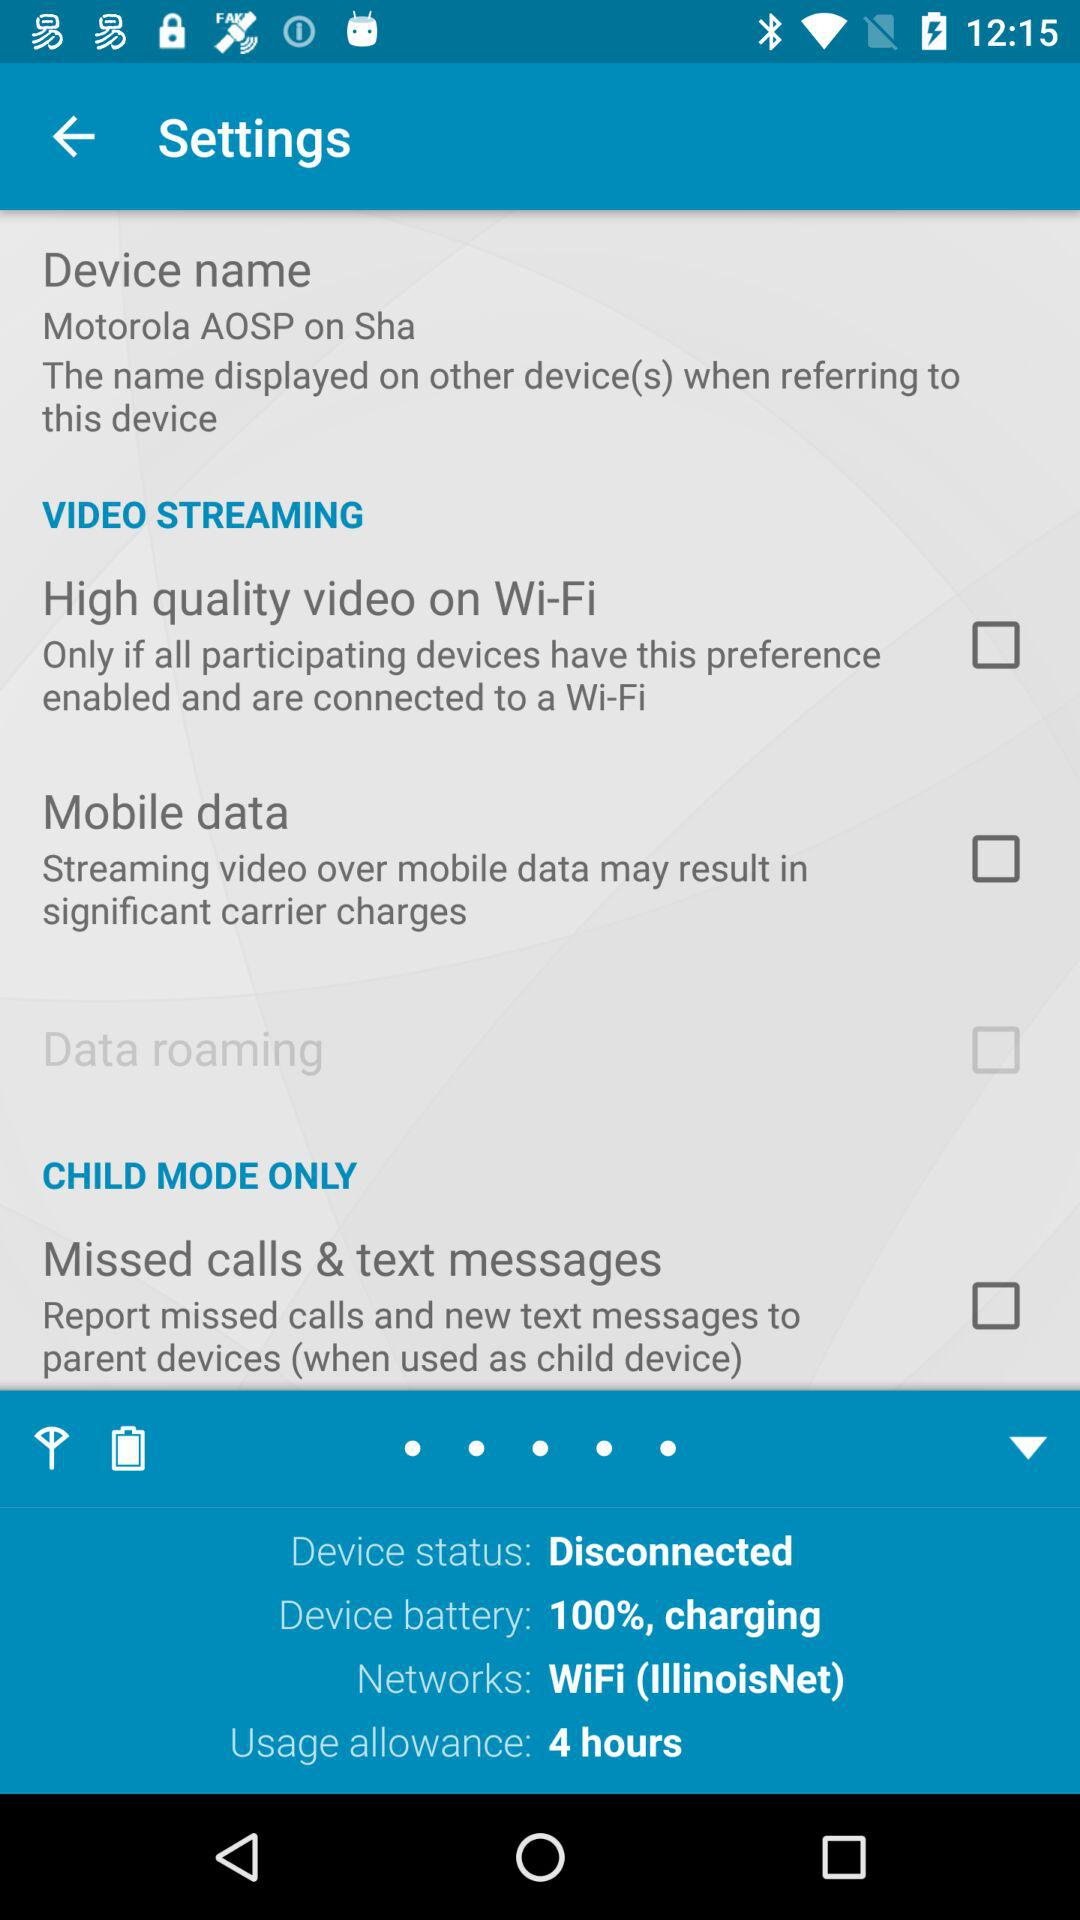What is the device's name? The device's name is "Motorola AOSP on Sha". 